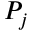<formula> <loc_0><loc_0><loc_500><loc_500>P _ { j }</formula> 